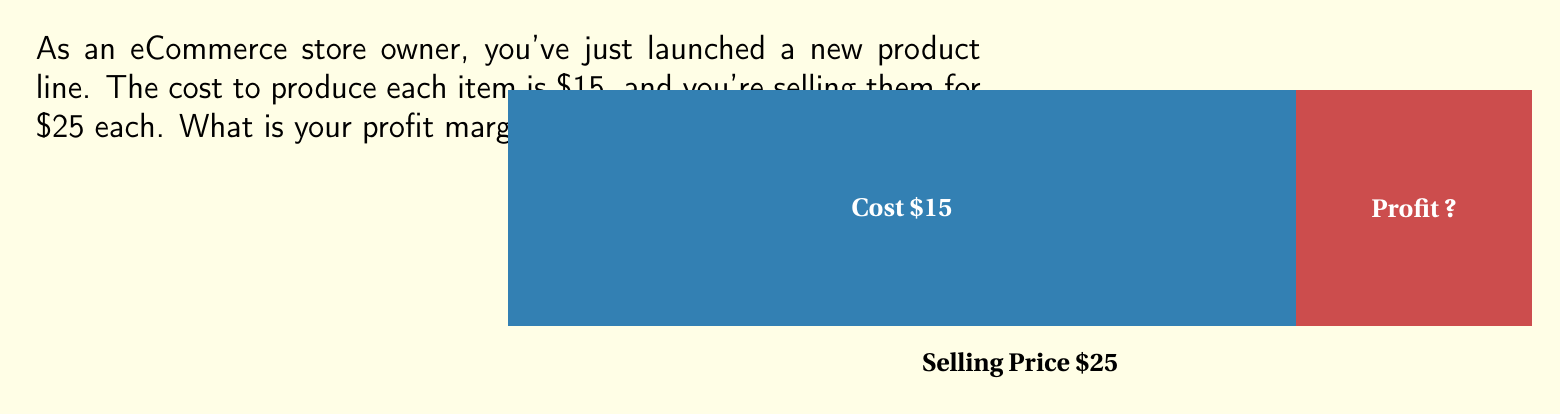What is the answer to this math problem? To calculate the profit margin percentage, we need to follow these steps:

1. Calculate the profit per item:
   Profit = Selling Price - Cost
   $$ \text{Profit} = $25 - $15 = $10 $$

2. Calculate the profit margin ratio:
   Profit Margin Ratio = Profit ÷ Selling Price
   $$ \text{Profit Margin Ratio} = \frac{$10}{$25} = 0.4 $$

3. Convert the ratio to a percentage:
   Profit Margin Percentage = Profit Margin Ratio × 100%
   $$ \text{Profit Margin Percentage} = 0.4 \times 100\% = 40\% $$

Therefore, the profit margin percentage on this product line is 40%.
Answer: 40% 